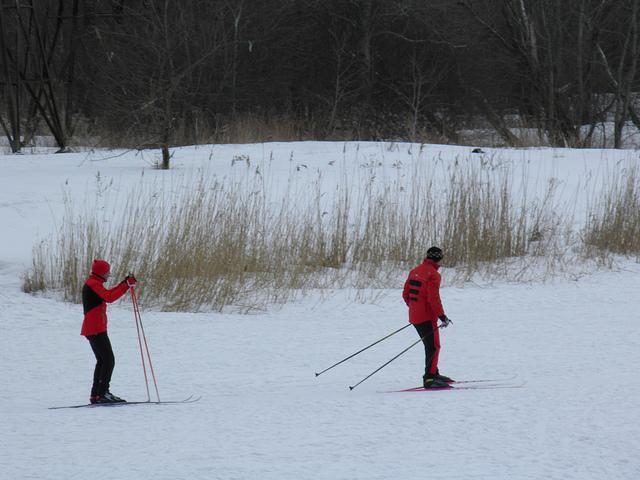How many ski poles do you see?
Give a very brief answer. 4. How many people are there?
Give a very brief answer. 2. 